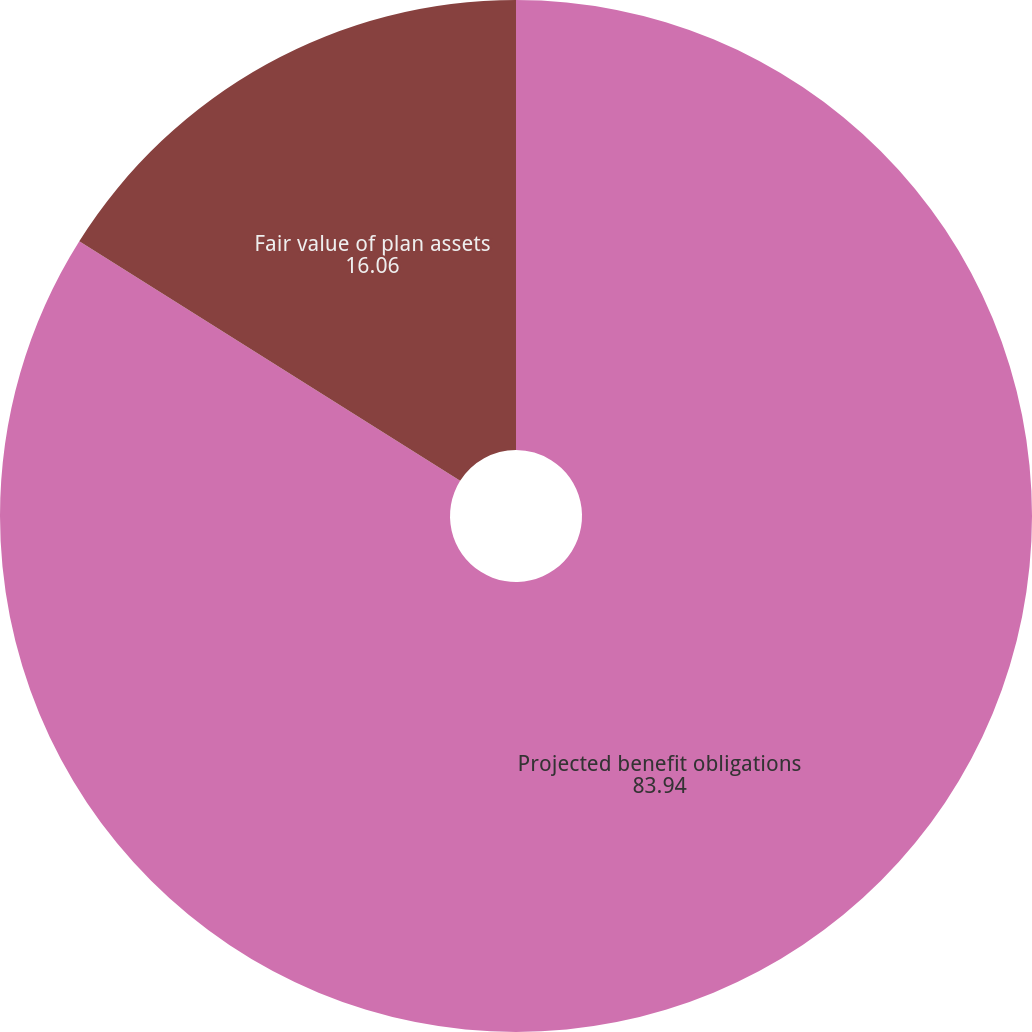Convert chart to OTSL. <chart><loc_0><loc_0><loc_500><loc_500><pie_chart><fcel>Projected benefit obligations<fcel>Fair value of plan assets<nl><fcel>83.94%<fcel>16.06%<nl></chart> 